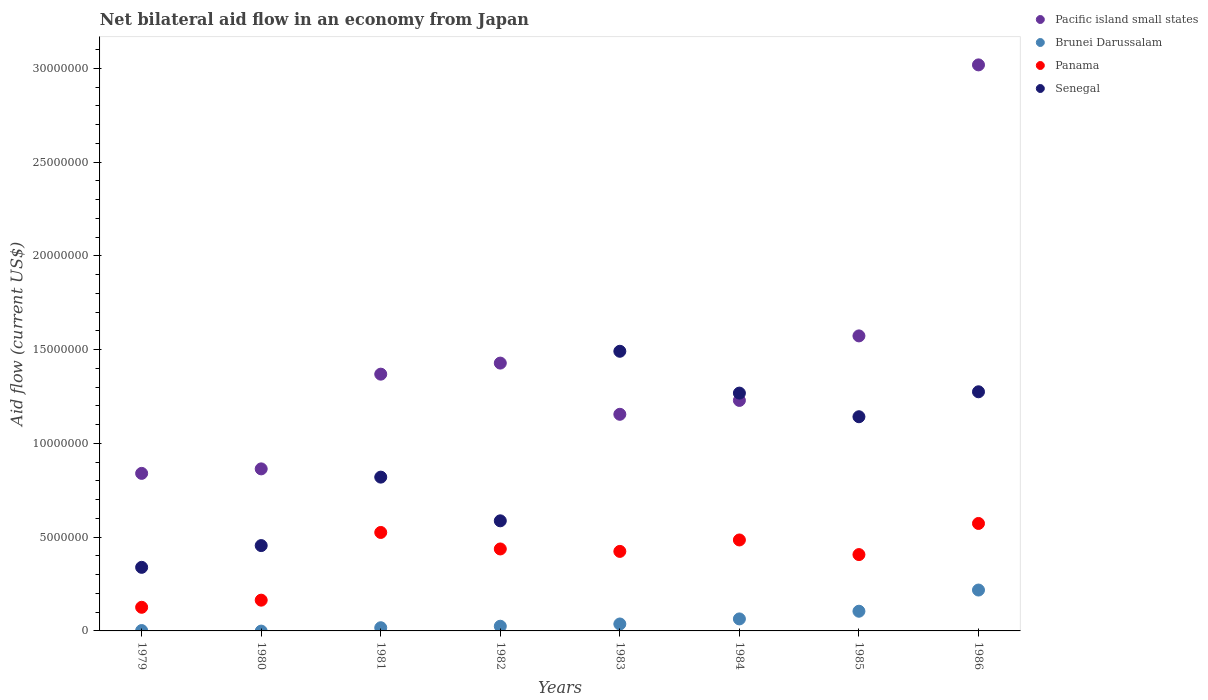Is the number of dotlines equal to the number of legend labels?
Your answer should be compact. No. What is the net bilateral aid flow in Pacific island small states in 1986?
Provide a short and direct response. 3.02e+07. Across all years, what is the maximum net bilateral aid flow in Panama?
Make the answer very short. 5.73e+06. Across all years, what is the minimum net bilateral aid flow in Senegal?
Offer a very short reply. 3.39e+06. What is the total net bilateral aid flow in Panama in the graph?
Provide a succinct answer. 3.14e+07. What is the difference between the net bilateral aid flow in Senegal in 1982 and that in 1983?
Ensure brevity in your answer.  -9.04e+06. What is the difference between the net bilateral aid flow in Brunei Darussalam in 1984 and the net bilateral aid flow in Pacific island small states in 1979?
Ensure brevity in your answer.  -7.76e+06. What is the average net bilateral aid flow in Senegal per year?
Your answer should be very brief. 9.22e+06. In the year 1985, what is the difference between the net bilateral aid flow in Senegal and net bilateral aid flow in Brunei Darussalam?
Your answer should be very brief. 1.04e+07. What is the ratio of the net bilateral aid flow in Brunei Darussalam in 1979 to that in 1983?
Give a very brief answer. 0.05. Is the net bilateral aid flow in Senegal in 1982 less than that in 1985?
Your response must be concise. Yes. Is the difference between the net bilateral aid flow in Senegal in 1981 and 1985 greater than the difference between the net bilateral aid flow in Brunei Darussalam in 1981 and 1985?
Provide a succinct answer. No. What is the difference between the highest and the lowest net bilateral aid flow in Senegal?
Provide a succinct answer. 1.15e+07. Is the net bilateral aid flow in Brunei Darussalam strictly greater than the net bilateral aid flow in Senegal over the years?
Provide a short and direct response. No. How many dotlines are there?
Make the answer very short. 4. What is the difference between two consecutive major ticks on the Y-axis?
Your answer should be compact. 5.00e+06. Are the values on the major ticks of Y-axis written in scientific E-notation?
Make the answer very short. No. Does the graph contain grids?
Provide a succinct answer. No. How many legend labels are there?
Offer a very short reply. 4. How are the legend labels stacked?
Keep it short and to the point. Vertical. What is the title of the graph?
Ensure brevity in your answer.  Net bilateral aid flow in an economy from Japan. What is the label or title of the X-axis?
Offer a terse response. Years. What is the Aid flow (current US$) in Pacific island small states in 1979?
Your answer should be very brief. 8.40e+06. What is the Aid flow (current US$) in Brunei Darussalam in 1979?
Your answer should be compact. 2.00e+04. What is the Aid flow (current US$) of Panama in 1979?
Your response must be concise. 1.26e+06. What is the Aid flow (current US$) in Senegal in 1979?
Provide a succinct answer. 3.39e+06. What is the Aid flow (current US$) in Pacific island small states in 1980?
Make the answer very short. 8.64e+06. What is the Aid flow (current US$) in Brunei Darussalam in 1980?
Provide a short and direct response. 0. What is the Aid flow (current US$) in Panama in 1980?
Your answer should be compact. 1.64e+06. What is the Aid flow (current US$) in Senegal in 1980?
Keep it short and to the point. 4.55e+06. What is the Aid flow (current US$) of Pacific island small states in 1981?
Ensure brevity in your answer.  1.37e+07. What is the Aid flow (current US$) in Panama in 1981?
Provide a succinct answer. 5.25e+06. What is the Aid flow (current US$) of Senegal in 1981?
Make the answer very short. 8.20e+06. What is the Aid flow (current US$) in Pacific island small states in 1982?
Make the answer very short. 1.43e+07. What is the Aid flow (current US$) in Brunei Darussalam in 1982?
Provide a short and direct response. 2.50e+05. What is the Aid flow (current US$) of Panama in 1982?
Offer a very short reply. 4.37e+06. What is the Aid flow (current US$) of Senegal in 1982?
Make the answer very short. 5.87e+06. What is the Aid flow (current US$) of Pacific island small states in 1983?
Keep it short and to the point. 1.16e+07. What is the Aid flow (current US$) in Brunei Darussalam in 1983?
Your response must be concise. 3.70e+05. What is the Aid flow (current US$) in Panama in 1983?
Provide a succinct answer. 4.24e+06. What is the Aid flow (current US$) in Senegal in 1983?
Keep it short and to the point. 1.49e+07. What is the Aid flow (current US$) in Pacific island small states in 1984?
Ensure brevity in your answer.  1.23e+07. What is the Aid flow (current US$) of Brunei Darussalam in 1984?
Offer a terse response. 6.40e+05. What is the Aid flow (current US$) of Panama in 1984?
Offer a terse response. 4.85e+06. What is the Aid flow (current US$) in Senegal in 1984?
Offer a very short reply. 1.27e+07. What is the Aid flow (current US$) in Pacific island small states in 1985?
Your answer should be compact. 1.57e+07. What is the Aid flow (current US$) of Brunei Darussalam in 1985?
Provide a short and direct response. 1.05e+06. What is the Aid flow (current US$) of Panama in 1985?
Your response must be concise. 4.07e+06. What is the Aid flow (current US$) in Senegal in 1985?
Your answer should be very brief. 1.14e+07. What is the Aid flow (current US$) of Pacific island small states in 1986?
Make the answer very short. 3.02e+07. What is the Aid flow (current US$) of Brunei Darussalam in 1986?
Offer a very short reply. 2.18e+06. What is the Aid flow (current US$) in Panama in 1986?
Ensure brevity in your answer.  5.73e+06. What is the Aid flow (current US$) in Senegal in 1986?
Provide a succinct answer. 1.28e+07. Across all years, what is the maximum Aid flow (current US$) in Pacific island small states?
Ensure brevity in your answer.  3.02e+07. Across all years, what is the maximum Aid flow (current US$) of Brunei Darussalam?
Make the answer very short. 2.18e+06. Across all years, what is the maximum Aid flow (current US$) of Panama?
Keep it short and to the point. 5.73e+06. Across all years, what is the maximum Aid flow (current US$) in Senegal?
Make the answer very short. 1.49e+07. Across all years, what is the minimum Aid flow (current US$) in Pacific island small states?
Your answer should be very brief. 8.40e+06. Across all years, what is the minimum Aid flow (current US$) of Brunei Darussalam?
Your answer should be compact. 0. Across all years, what is the minimum Aid flow (current US$) in Panama?
Offer a terse response. 1.26e+06. Across all years, what is the minimum Aid flow (current US$) of Senegal?
Make the answer very short. 3.39e+06. What is the total Aid flow (current US$) in Pacific island small states in the graph?
Provide a short and direct response. 1.15e+08. What is the total Aid flow (current US$) in Brunei Darussalam in the graph?
Keep it short and to the point. 4.68e+06. What is the total Aid flow (current US$) in Panama in the graph?
Offer a very short reply. 3.14e+07. What is the total Aid flow (current US$) of Senegal in the graph?
Offer a terse response. 7.38e+07. What is the difference between the Aid flow (current US$) of Pacific island small states in 1979 and that in 1980?
Offer a very short reply. -2.40e+05. What is the difference between the Aid flow (current US$) in Panama in 1979 and that in 1980?
Your answer should be compact. -3.80e+05. What is the difference between the Aid flow (current US$) in Senegal in 1979 and that in 1980?
Your answer should be compact. -1.16e+06. What is the difference between the Aid flow (current US$) of Pacific island small states in 1979 and that in 1981?
Give a very brief answer. -5.29e+06. What is the difference between the Aid flow (current US$) of Panama in 1979 and that in 1981?
Provide a short and direct response. -3.99e+06. What is the difference between the Aid flow (current US$) in Senegal in 1979 and that in 1981?
Your answer should be compact. -4.81e+06. What is the difference between the Aid flow (current US$) of Pacific island small states in 1979 and that in 1982?
Provide a short and direct response. -5.88e+06. What is the difference between the Aid flow (current US$) in Brunei Darussalam in 1979 and that in 1982?
Ensure brevity in your answer.  -2.30e+05. What is the difference between the Aid flow (current US$) in Panama in 1979 and that in 1982?
Give a very brief answer. -3.11e+06. What is the difference between the Aid flow (current US$) of Senegal in 1979 and that in 1982?
Provide a short and direct response. -2.48e+06. What is the difference between the Aid flow (current US$) of Pacific island small states in 1979 and that in 1983?
Give a very brief answer. -3.15e+06. What is the difference between the Aid flow (current US$) of Brunei Darussalam in 1979 and that in 1983?
Your answer should be very brief. -3.50e+05. What is the difference between the Aid flow (current US$) of Panama in 1979 and that in 1983?
Keep it short and to the point. -2.98e+06. What is the difference between the Aid flow (current US$) in Senegal in 1979 and that in 1983?
Provide a short and direct response. -1.15e+07. What is the difference between the Aid flow (current US$) in Pacific island small states in 1979 and that in 1984?
Keep it short and to the point. -3.89e+06. What is the difference between the Aid flow (current US$) of Brunei Darussalam in 1979 and that in 1984?
Give a very brief answer. -6.20e+05. What is the difference between the Aid flow (current US$) of Panama in 1979 and that in 1984?
Give a very brief answer. -3.59e+06. What is the difference between the Aid flow (current US$) in Senegal in 1979 and that in 1984?
Offer a very short reply. -9.29e+06. What is the difference between the Aid flow (current US$) in Pacific island small states in 1979 and that in 1985?
Ensure brevity in your answer.  -7.33e+06. What is the difference between the Aid flow (current US$) in Brunei Darussalam in 1979 and that in 1985?
Keep it short and to the point. -1.03e+06. What is the difference between the Aid flow (current US$) of Panama in 1979 and that in 1985?
Give a very brief answer. -2.81e+06. What is the difference between the Aid flow (current US$) of Senegal in 1979 and that in 1985?
Offer a terse response. -8.03e+06. What is the difference between the Aid flow (current US$) in Pacific island small states in 1979 and that in 1986?
Keep it short and to the point. -2.18e+07. What is the difference between the Aid flow (current US$) of Brunei Darussalam in 1979 and that in 1986?
Keep it short and to the point. -2.16e+06. What is the difference between the Aid flow (current US$) in Panama in 1979 and that in 1986?
Offer a very short reply. -4.47e+06. What is the difference between the Aid flow (current US$) of Senegal in 1979 and that in 1986?
Ensure brevity in your answer.  -9.36e+06. What is the difference between the Aid flow (current US$) in Pacific island small states in 1980 and that in 1981?
Your response must be concise. -5.05e+06. What is the difference between the Aid flow (current US$) of Panama in 1980 and that in 1981?
Give a very brief answer. -3.61e+06. What is the difference between the Aid flow (current US$) of Senegal in 1980 and that in 1981?
Your response must be concise. -3.65e+06. What is the difference between the Aid flow (current US$) in Pacific island small states in 1980 and that in 1982?
Your answer should be very brief. -5.64e+06. What is the difference between the Aid flow (current US$) of Panama in 1980 and that in 1982?
Your answer should be compact. -2.73e+06. What is the difference between the Aid flow (current US$) of Senegal in 1980 and that in 1982?
Your answer should be compact. -1.32e+06. What is the difference between the Aid flow (current US$) in Pacific island small states in 1980 and that in 1983?
Give a very brief answer. -2.91e+06. What is the difference between the Aid flow (current US$) in Panama in 1980 and that in 1983?
Your answer should be compact. -2.60e+06. What is the difference between the Aid flow (current US$) of Senegal in 1980 and that in 1983?
Your answer should be compact. -1.04e+07. What is the difference between the Aid flow (current US$) in Pacific island small states in 1980 and that in 1984?
Provide a succinct answer. -3.65e+06. What is the difference between the Aid flow (current US$) in Panama in 1980 and that in 1984?
Provide a succinct answer. -3.21e+06. What is the difference between the Aid flow (current US$) in Senegal in 1980 and that in 1984?
Provide a succinct answer. -8.13e+06. What is the difference between the Aid flow (current US$) in Pacific island small states in 1980 and that in 1985?
Your answer should be compact. -7.09e+06. What is the difference between the Aid flow (current US$) in Panama in 1980 and that in 1985?
Your answer should be very brief. -2.43e+06. What is the difference between the Aid flow (current US$) of Senegal in 1980 and that in 1985?
Your answer should be very brief. -6.87e+06. What is the difference between the Aid flow (current US$) of Pacific island small states in 1980 and that in 1986?
Offer a terse response. -2.15e+07. What is the difference between the Aid flow (current US$) of Panama in 1980 and that in 1986?
Offer a terse response. -4.09e+06. What is the difference between the Aid flow (current US$) in Senegal in 1980 and that in 1986?
Keep it short and to the point. -8.20e+06. What is the difference between the Aid flow (current US$) of Pacific island small states in 1981 and that in 1982?
Your answer should be compact. -5.90e+05. What is the difference between the Aid flow (current US$) of Panama in 1981 and that in 1982?
Your response must be concise. 8.80e+05. What is the difference between the Aid flow (current US$) of Senegal in 1981 and that in 1982?
Offer a very short reply. 2.33e+06. What is the difference between the Aid flow (current US$) of Pacific island small states in 1981 and that in 1983?
Give a very brief answer. 2.14e+06. What is the difference between the Aid flow (current US$) of Panama in 1981 and that in 1983?
Provide a succinct answer. 1.01e+06. What is the difference between the Aid flow (current US$) in Senegal in 1981 and that in 1983?
Provide a short and direct response. -6.71e+06. What is the difference between the Aid flow (current US$) of Pacific island small states in 1981 and that in 1984?
Your answer should be compact. 1.40e+06. What is the difference between the Aid flow (current US$) in Brunei Darussalam in 1981 and that in 1984?
Make the answer very short. -4.70e+05. What is the difference between the Aid flow (current US$) in Panama in 1981 and that in 1984?
Your answer should be compact. 4.00e+05. What is the difference between the Aid flow (current US$) in Senegal in 1981 and that in 1984?
Your answer should be very brief. -4.48e+06. What is the difference between the Aid flow (current US$) of Pacific island small states in 1981 and that in 1985?
Provide a short and direct response. -2.04e+06. What is the difference between the Aid flow (current US$) in Brunei Darussalam in 1981 and that in 1985?
Offer a very short reply. -8.80e+05. What is the difference between the Aid flow (current US$) of Panama in 1981 and that in 1985?
Make the answer very short. 1.18e+06. What is the difference between the Aid flow (current US$) in Senegal in 1981 and that in 1985?
Your answer should be very brief. -3.22e+06. What is the difference between the Aid flow (current US$) in Pacific island small states in 1981 and that in 1986?
Make the answer very short. -1.65e+07. What is the difference between the Aid flow (current US$) in Brunei Darussalam in 1981 and that in 1986?
Offer a very short reply. -2.01e+06. What is the difference between the Aid flow (current US$) in Panama in 1981 and that in 1986?
Keep it short and to the point. -4.80e+05. What is the difference between the Aid flow (current US$) in Senegal in 1981 and that in 1986?
Your answer should be very brief. -4.55e+06. What is the difference between the Aid flow (current US$) in Pacific island small states in 1982 and that in 1983?
Your answer should be compact. 2.73e+06. What is the difference between the Aid flow (current US$) of Brunei Darussalam in 1982 and that in 1983?
Provide a short and direct response. -1.20e+05. What is the difference between the Aid flow (current US$) of Senegal in 1982 and that in 1983?
Ensure brevity in your answer.  -9.04e+06. What is the difference between the Aid flow (current US$) of Pacific island small states in 1982 and that in 1984?
Keep it short and to the point. 1.99e+06. What is the difference between the Aid flow (current US$) in Brunei Darussalam in 1982 and that in 1984?
Make the answer very short. -3.90e+05. What is the difference between the Aid flow (current US$) in Panama in 1982 and that in 1984?
Keep it short and to the point. -4.80e+05. What is the difference between the Aid flow (current US$) of Senegal in 1982 and that in 1984?
Give a very brief answer. -6.81e+06. What is the difference between the Aid flow (current US$) in Pacific island small states in 1982 and that in 1985?
Keep it short and to the point. -1.45e+06. What is the difference between the Aid flow (current US$) of Brunei Darussalam in 1982 and that in 1985?
Your answer should be very brief. -8.00e+05. What is the difference between the Aid flow (current US$) of Senegal in 1982 and that in 1985?
Make the answer very short. -5.55e+06. What is the difference between the Aid flow (current US$) of Pacific island small states in 1982 and that in 1986?
Provide a short and direct response. -1.59e+07. What is the difference between the Aid flow (current US$) of Brunei Darussalam in 1982 and that in 1986?
Your answer should be very brief. -1.93e+06. What is the difference between the Aid flow (current US$) in Panama in 1982 and that in 1986?
Offer a terse response. -1.36e+06. What is the difference between the Aid flow (current US$) in Senegal in 1982 and that in 1986?
Provide a short and direct response. -6.88e+06. What is the difference between the Aid flow (current US$) in Pacific island small states in 1983 and that in 1984?
Provide a succinct answer. -7.40e+05. What is the difference between the Aid flow (current US$) of Brunei Darussalam in 1983 and that in 1984?
Offer a terse response. -2.70e+05. What is the difference between the Aid flow (current US$) in Panama in 1983 and that in 1984?
Offer a terse response. -6.10e+05. What is the difference between the Aid flow (current US$) of Senegal in 1983 and that in 1984?
Your response must be concise. 2.23e+06. What is the difference between the Aid flow (current US$) of Pacific island small states in 1983 and that in 1985?
Your answer should be very brief. -4.18e+06. What is the difference between the Aid flow (current US$) in Brunei Darussalam in 1983 and that in 1985?
Ensure brevity in your answer.  -6.80e+05. What is the difference between the Aid flow (current US$) of Senegal in 1983 and that in 1985?
Keep it short and to the point. 3.49e+06. What is the difference between the Aid flow (current US$) in Pacific island small states in 1983 and that in 1986?
Give a very brief answer. -1.86e+07. What is the difference between the Aid flow (current US$) in Brunei Darussalam in 1983 and that in 1986?
Provide a short and direct response. -1.81e+06. What is the difference between the Aid flow (current US$) in Panama in 1983 and that in 1986?
Offer a terse response. -1.49e+06. What is the difference between the Aid flow (current US$) in Senegal in 1983 and that in 1986?
Give a very brief answer. 2.16e+06. What is the difference between the Aid flow (current US$) of Pacific island small states in 1984 and that in 1985?
Make the answer very short. -3.44e+06. What is the difference between the Aid flow (current US$) of Brunei Darussalam in 1984 and that in 1985?
Make the answer very short. -4.10e+05. What is the difference between the Aid flow (current US$) in Panama in 1984 and that in 1985?
Your answer should be compact. 7.80e+05. What is the difference between the Aid flow (current US$) in Senegal in 1984 and that in 1985?
Provide a short and direct response. 1.26e+06. What is the difference between the Aid flow (current US$) in Pacific island small states in 1984 and that in 1986?
Keep it short and to the point. -1.79e+07. What is the difference between the Aid flow (current US$) in Brunei Darussalam in 1984 and that in 1986?
Keep it short and to the point. -1.54e+06. What is the difference between the Aid flow (current US$) in Panama in 1984 and that in 1986?
Your answer should be compact. -8.80e+05. What is the difference between the Aid flow (current US$) in Senegal in 1984 and that in 1986?
Offer a terse response. -7.00e+04. What is the difference between the Aid flow (current US$) in Pacific island small states in 1985 and that in 1986?
Ensure brevity in your answer.  -1.44e+07. What is the difference between the Aid flow (current US$) in Brunei Darussalam in 1985 and that in 1986?
Your answer should be compact. -1.13e+06. What is the difference between the Aid flow (current US$) of Panama in 1985 and that in 1986?
Provide a short and direct response. -1.66e+06. What is the difference between the Aid flow (current US$) in Senegal in 1985 and that in 1986?
Keep it short and to the point. -1.33e+06. What is the difference between the Aid flow (current US$) of Pacific island small states in 1979 and the Aid flow (current US$) of Panama in 1980?
Provide a short and direct response. 6.76e+06. What is the difference between the Aid flow (current US$) in Pacific island small states in 1979 and the Aid flow (current US$) in Senegal in 1980?
Offer a very short reply. 3.85e+06. What is the difference between the Aid flow (current US$) of Brunei Darussalam in 1979 and the Aid flow (current US$) of Panama in 1980?
Your response must be concise. -1.62e+06. What is the difference between the Aid flow (current US$) of Brunei Darussalam in 1979 and the Aid flow (current US$) of Senegal in 1980?
Ensure brevity in your answer.  -4.53e+06. What is the difference between the Aid flow (current US$) in Panama in 1979 and the Aid flow (current US$) in Senegal in 1980?
Ensure brevity in your answer.  -3.29e+06. What is the difference between the Aid flow (current US$) in Pacific island small states in 1979 and the Aid flow (current US$) in Brunei Darussalam in 1981?
Your answer should be compact. 8.23e+06. What is the difference between the Aid flow (current US$) in Pacific island small states in 1979 and the Aid flow (current US$) in Panama in 1981?
Offer a very short reply. 3.15e+06. What is the difference between the Aid flow (current US$) of Brunei Darussalam in 1979 and the Aid flow (current US$) of Panama in 1981?
Provide a succinct answer. -5.23e+06. What is the difference between the Aid flow (current US$) in Brunei Darussalam in 1979 and the Aid flow (current US$) in Senegal in 1981?
Your answer should be compact. -8.18e+06. What is the difference between the Aid flow (current US$) of Panama in 1979 and the Aid flow (current US$) of Senegal in 1981?
Make the answer very short. -6.94e+06. What is the difference between the Aid flow (current US$) in Pacific island small states in 1979 and the Aid flow (current US$) in Brunei Darussalam in 1982?
Your response must be concise. 8.15e+06. What is the difference between the Aid flow (current US$) of Pacific island small states in 1979 and the Aid flow (current US$) of Panama in 1982?
Your answer should be very brief. 4.03e+06. What is the difference between the Aid flow (current US$) of Pacific island small states in 1979 and the Aid flow (current US$) of Senegal in 1982?
Provide a succinct answer. 2.53e+06. What is the difference between the Aid flow (current US$) in Brunei Darussalam in 1979 and the Aid flow (current US$) in Panama in 1982?
Your answer should be compact. -4.35e+06. What is the difference between the Aid flow (current US$) in Brunei Darussalam in 1979 and the Aid flow (current US$) in Senegal in 1982?
Your answer should be very brief. -5.85e+06. What is the difference between the Aid flow (current US$) in Panama in 1979 and the Aid flow (current US$) in Senegal in 1982?
Provide a short and direct response. -4.61e+06. What is the difference between the Aid flow (current US$) in Pacific island small states in 1979 and the Aid flow (current US$) in Brunei Darussalam in 1983?
Provide a short and direct response. 8.03e+06. What is the difference between the Aid flow (current US$) of Pacific island small states in 1979 and the Aid flow (current US$) of Panama in 1983?
Provide a succinct answer. 4.16e+06. What is the difference between the Aid flow (current US$) of Pacific island small states in 1979 and the Aid flow (current US$) of Senegal in 1983?
Keep it short and to the point. -6.51e+06. What is the difference between the Aid flow (current US$) of Brunei Darussalam in 1979 and the Aid flow (current US$) of Panama in 1983?
Ensure brevity in your answer.  -4.22e+06. What is the difference between the Aid flow (current US$) in Brunei Darussalam in 1979 and the Aid flow (current US$) in Senegal in 1983?
Provide a short and direct response. -1.49e+07. What is the difference between the Aid flow (current US$) in Panama in 1979 and the Aid flow (current US$) in Senegal in 1983?
Give a very brief answer. -1.36e+07. What is the difference between the Aid flow (current US$) in Pacific island small states in 1979 and the Aid flow (current US$) in Brunei Darussalam in 1984?
Ensure brevity in your answer.  7.76e+06. What is the difference between the Aid flow (current US$) in Pacific island small states in 1979 and the Aid flow (current US$) in Panama in 1984?
Provide a short and direct response. 3.55e+06. What is the difference between the Aid flow (current US$) of Pacific island small states in 1979 and the Aid flow (current US$) of Senegal in 1984?
Provide a short and direct response. -4.28e+06. What is the difference between the Aid flow (current US$) in Brunei Darussalam in 1979 and the Aid flow (current US$) in Panama in 1984?
Your answer should be very brief. -4.83e+06. What is the difference between the Aid flow (current US$) in Brunei Darussalam in 1979 and the Aid flow (current US$) in Senegal in 1984?
Give a very brief answer. -1.27e+07. What is the difference between the Aid flow (current US$) in Panama in 1979 and the Aid flow (current US$) in Senegal in 1984?
Your response must be concise. -1.14e+07. What is the difference between the Aid flow (current US$) in Pacific island small states in 1979 and the Aid flow (current US$) in Brunei Darussalam in 1985?
Offer a terse response. 7.35e+06. What is the difference between the Aid flow (current US$) of Pacific island small states in 1979 and the Aid flow (current US$) of Panama in 1985?
Provide a succinct answer. 4.33e+06. What is the difference between the Aid flow (current US$) in Pacific island small states in 1979 and the Aid flow (current US$) in Senegal in 1985?
Your answer should be compact. -3.02e+06. What is the difference between the Aid flow (current US$) of Brunei Darussalam in 1979 and the Aid flow (current US$) of Panama in 1985?
Ensure brevity in your answer.  -4.05e+06. What is the difference between the Aid flow (current US$) of Brunei Darussalam in 1979 and the Aid flow (current US$) of Senegal in 1985?
Your response must be concise. -1.14e+07. What is the difference between the Aid flow (current US$) in Panama in 1979 and the Aid flow (current US$) in Senegal in 1985?
Give a very brief answer. -1.02e+07. What is the difference between the Aid flow (current US$) of Pacific island small states in 1979 and the Aid flow (current US$) of Brunei Darussalam in 1986?
Keep it short and to the point. 6.22e+06. What is the difference between the Aid flow (current US$) in Pacific island small states in 1979 and the Aid flow (current US$) in Panama in 1986?
Your answer should be very brief. 2.67e+06. What is the difference between the Aid flow (current US$) of Pacific island small states in 1979 and the Aid flow (current US$) of Senegal in 1986?
Your answer should be compact. -4.35e+06. What is the difference between the Aid flow (current US$) in Brunei Darussalam in 1979 and the Aid flow (current US$) in Panama in 1986?
Keep it short and to the point. -5.71e+06. What is the difference between the Aid flow (current US$) in Brunei Darussalam in 1979 and the Aid flow (current US$) in Senegal in 1986?
Your answer should be very brief. -1.27e+07. What is the difference between the Aid flow (current US$) in Panama in 1979 and the Aid flow (current US$) in Senegal in 1986?
Keep it short and to the point. -1.15e+07. What is the difference between the Aid flow (current US$) of Pacific island small states in 1980 and the Aid flow (current US$) of Brunei Darussalam in 1981?
Your response must be concise. 8.47e+06. What is the difference between the Aid flow (current US$) of Pacific island small states in 1980 and the Aid flow (current US$) of Panama in 1981?
Your response must be concise. 3.39e+06. What is the difference between the Aid flow (current US$) in Pacific island small states in 1980 and the Aid flow (current US$) in Senegal in 1981?
Keep it short and to the point. 4.40e+05. What is the difference between the Aid flow (current US$) of Panama in 1980 and the Aid flow (current US$) of Senegal in 1981?
Give a very brief answer. -6.56e+06. What is the difference between the Aid flow (current US$) in Pacific island small states in 1980 and the Aid flow (current US$) in Brunei Darussalam in 1982?
Make the answer very short. 8.39e+06. What is the difference between the Aid flow (current US$) of Pacific island small states in 1980 and the Aid flow (current US$) of Panama in 1982?
Your answer should be compact. 4.27e+06. What is the difference between the Aid flow (current US$) in Pacific island small states in 1980 and the Aid flow (current US$) in Senegal in 1982?
Your answer should be very brief. 2.77e+06. What is the difference between the Aid flow (current US$) of Panama in 1980 and the Aid flow (current US$) of Senegal in 1982?
Provide a succinct answer. -4.23e+06. What is the difference between the Aid flow (current US$) of Pacific island small states in 1980 and the Aid flow (current US$) of Brunei Darussalam in 1983?
Give a very brief answer. 8.27e+06. What is the difference between the Aid flow (current US$) of Pacific island small states in 1980 and the Aid flow (current US$) of Panama in 1983?
Offer a terse response. 4.40e+06. What is the difference between the Aid flow (current US$) in Pacific island small states in 1980 and the Aid flow (current US$) in Senegal in 1983?
Keep it short and to the point. -6.27e+06. What is the difference between the Aid flow (current US$) of Panama in 1980 and the Aid flow (current US$) of Senegal in 1983?
Your response must be concise. -1.33e+07. What is the difference between the Aid flow (current US$) in Pacific island small states in 1980 and the Aid flow (current US$) in Brunei Darussalam in 1984?
Keep it short and to the point. 8.00e+06. What is the difference between the Aid flow (current US$) of Pacific island small states in 1980 and the Aid flow (current US$) of Panama in 1984?
Ensure brevity in your answer.  3.79e+06. What is the difference between the Aid flow (current US$) in Pacific island small states in 1980 and the Aid flow (current US$) in Senegal in 1984?
Offer a terse response. -4.04e+06. What is the difference between the Aid flow (current US$) in Panama in 1980 and the Aid flow (current US$) in Senegal in 1984?
Keep it short and to the point. -1.10e+07. What is the difference between the Aid flow (current US$) in Pacific island small states in 1980 and the Aid flow (current US$) in Brunei Darussalam in 1985?
Make the answer very short. 7.59e+06. What is the difference between the Aid flow (current US$) of Pacific island small states in 1980 and the Aid flow (current US$) of Panama in 1985?
Make the answer very short. 4.57e+06. What is the difference between the Aid flow (current US$) of Pacific island small states in 1980 and the Aid flow (current US$) of Senegal in 1985?
Provide a succinct answer. -2.78e+06. What is the difference between the Aid flow (current US$) of Panama in 1980 and the Aid flow (current US$) of Senegal in 1985?
Provide a short and direct response. -9.78e+06. What is the difference between the Aid flow (current US$) of Pacific island small states in 1980 and the Aid flow (current US$) of Brunei Darussalam in 1986?
Your answer should be compact. 6.46e+06. What is the difference between the Aid flow (current US$) in Pacific island small states in 1980 and the Aid flow (current US$) in Panama in 1986?
Ensure brevity in your answer.  2.91e+06. What is the difference between the Aid flow (current US$) of Pacific island small states in 1980 and the Aid flow (current US$) of Senegal in 1986?
Provide a short and direct response. -4.11e+06. What is the difference between the Aid flow (current US$) of Panama in 1980 and the Aid flow (current US$) of Senegal in 1986?
Ensure brevity in your answer.  -1.11e+07. What is the difference between the Aid flow (current US$) of Pacific island small states in 1981 and the Aid flow (current US$) of Brunei Darussalam in 1982?
Make the answer very short. 1.34e+07. What is the difference between the Aid flow (current US$) in Pacific island small states in 1981 and the Aid flow (current US$) in Panama in 1982?
Provide a succinct answer. 9.32e+06. What is the difference between the Aid flow (current US$) in Pacific island small states in 1981 and the Aid flow (current US$) in Senegal in 1982?
Ensure brevity in your answer.  7.82e+06. What is the difference between the Aid flow (current US$) of Brunei Darussalam in 1981 and the Aid flow (current US$) of Panama in 1982?
Keep it short and to the point. -4.20e+06. What is the difference between the Aid flow (current US$) in Brunei Darussalam in 1981 and the Aid flow (current US$) in Senegal in 1982?
Keep it short and to the point. -5.70e+06. What is the difference between the Aid flow (current US$) in Panama in 1981 and the Aid flow (current US$) in Senegal in 1982?
Offer a very short reply. -6.20e+05. What is the difference between the Aid flow (current US$) of Pacific island small states in 1981 and the Aid flow (current US$) of Brunei Darussalam in 1983?
Your answer should be very brief. 1.33e+07. What is the difference between the Aid flow (current US$) in Pacific island small states in 1981 and the Aid flow (current US$) in Panama in 1983?
Provide a succinct answer. 9.45e+06. What is the difference between the Aid flow (current US$) of Pacific island small states in 1981 and the Aid flow (current US$) of Senegal in 1983?
Your answer should be very brief. -1.22e+06. What is the difference between the Aid flow (current US$) of Brunei Darussalam in 1981 and the Aid flow (current US$) of Panama in 1983?
Give a very brief answer. -4.07e+06. What is the difference between the Aid flow (current US$) in Brunei Darussalam in 1981 and the Aid flow (current US$) in Senegal in 1983?
Ensure brevity in your answer.  -1.47e+07. What is the difference between the Aid flow (current US$) in Panama in 1981 and the Aid flow (current US$) in Senegal in 1983?
Ensure brevity in your answer.  -9.66e+06. What is the difference between the Aid flow (current US$) of Pacific island small states in 1981 and the Aid flow (current US$) of Brunei Darussalam in 1984?
Offer a terse response. 1.30e+07. What is the difference between the Aid flow (current US$) of Pacific island small states in 1981 and the Aid flow (current US$) of Panama in 1984?
Provide a short and direct response. 8.84e+06. What is the difference between the Aid flow (current US$) of Pacific island small states in 1981 and the Aid flow (current US$) of Senegal in 1984?
Offer a terse response. 1.01e+06. What is the difference between the Aid flow (current US$) of Brunei Darussalam in 1981 and the Aid flow (current US$) of Panama in 1984?
Your answer should be compact. -4.68e+06. What is the difference between the Aid flow (current US$) of Brunei Darussalam in 1981 and the Aid flow (current US$) of Senegal in 1984?
Offer a terse response. -1.25e+07. What is the difference between the Aid flow (current US$) in Panama in 1981 and the Aid flow (current US$) in Senegal in 1984?
Offer a very short reply. -7.43e+06. What is the difference between the Aid flow (current US$) in Pacific island small states in 1981 and the Aid flow (current US$) in Brunei Darussalam in 1985?
Make the answer very short. 1.26e+07. What is the difference between the Aid flow (current US$) of Pacific island small states in 1981 and the Aid flow (current US$) of Panama in 1985?
Offer a very short reply. 9.62e+06. What is the difference between the Aid flow (current US$) in Pacific island small states in 1981 and the Aid flow (current US$) in Senegal in 1985?
Your answer should be very brief. 2.27e+06. What is the difference between the Aid flow (current US$) in Brunei Darussalam in 1981 and the Aid flow (current US$) in Panama in 1985?
Make the answer very short. -3.90e+06. What is the difference between the Aid flow (current US$) of Brunei Darussalam in 1981 and the Aid flow (current US$) of Senegal in 1985?
Make the answer very short. -1.12e+07. What is the difference between the Aid flow (current US$) in Panama in 1981 and the Aid flow (current US$) in Senegal in 1985?
Offer a very short reply. -6.17e+06. What is the difference between the Aid flow (current US$) in Pacific island small states in 1981 and the Aid flow (current US$) in Brunei Darussalam in 1986?
Keep it short and to the point. 1.15e+07. What is the difference between the Aid flow (current US$) of Pacific island small states in 1981 and the Aid flow (current US$) of Panama in 1986?
Provide a succinct answer. 7.96e+06. What is the difference between the Aid flow (current US$) of Pacific island small states in 1981 and the Aid flow (current US$) of Senegal in 1986?
Ensure brevity in your answer.  9.40e+05. What is the difference between the Aid flow (current US$) of Brunei Darussalam in 1981 and the Aid flow (current US$) of Panama in 1986?
Provide a succinct answer. -5.56e+06. What is the difference between the Aid flow (current US$) of Brunei Darussalam in 1981 and the Aid flow (current US$) of Senegal in 1986?
Your answer should be very brief. -1.26e+07. What is the difference between the Aid flow (current US$) in Panama in 1981 and the Aid flow (current US$) in Senegal in 1986?
Your answer should be compact. -7.50e+06. What is the difference between the Aid flow (current US$) in Pacific island small states in 1982 and the Aid flow (current US$) in Brunei Darussalam in 1983?
Provide a short and direct response. 1.39e+07. What is the difference between the Aid flow (current US$) in Pacific island small states in 1982 and the Aid flow (current US$) in Panama in 1983?
Your answer should be compact. 1.00e+07. What is the difference between the Aid flow (current US$) of Pacific island small states in 1982 and the Aid flow (current US$) of Senegal in 1983?
Provide a short and direct response. -6.30e+05. What is the difference between the Aid flow (current US$) of Brunei Darussalam in 1982 and the Aid flow (current US$) of Panama in 1983?
Ensure brevity in your answer.  -3.99e+06. What is the difference between the Aid flow (current US$) in Brunei Darussalam in 1982 and the Aid flow (current US$) in Senegal in 1983?
Provide a short and direct response. -1.47e+07. What is the difference between the Aid flow (current US$) of Panama in 1982 and the Aid flow (current US$) of Senegal in 1983?
Offer a very short reply. -1.05e+07. What is the difference between the Aid flow (current US$) of Pacific island small states in 1982 and the Aid flow (current US$) of Brunei Darussalam in 1984?
Make the answer very short. 1.36e+07. What is the difference between the Aid flow (current US$) in Pacific island small states in 1982 and the Aid flow (current US$) in Panama in 1984?
Give a very brief answer. 9.43e+06. What is the difference between the Aid flow (current US$) in Pacific island small states in 1982 and the Aid flow (current US$) in Senegal in 1984?
Your response must be concise. 1.60e+06. What is the difference between the Aid flow (current US$) of Brunei Darussalam in 1982 and the Aid flow (current US$) of Panama in 1984?
Offer a terse response. -4.60e+06. What is the difference between the Aid flow (current US$) in Brunei Darussalam in 1982 and the Aid flow (current US$) in Senegal in 1984?
Keep it short and to the point. -1.24e+07. What is the difference between the Aid flow (current US$) in Panama in 1982 and the Aid flow (current US$) in Senegal in 1984?
Make the answer very short. -8.31e+06. What is the difference between the Aid flow (current US$) in Pacific island small states in 1982 and the Aid flow (current US$) in Brunei Darussalam in 1985?
Give a very brief answer. 1.32e+07. What is the difference between the Aid flow (current US$) in Pacific island small states in 1982 and the Aid flow (current US$) in Panama in 1985?
Provide a short and direct response. 1.02e+07. What is the difference between the Aid flow (current US$) in Pacific island small states in 1982 and the Aid flow (current US$) in Senegal in 1985?
Your response must be concise. 2.86e+06. What is the difference between the Aid flow (current US$) in Brunei Darussalam in 1982 and the Aid flow (current US$) in Panama in 1985?
Make the answer very short. -3.82e+06. What is the difference between the Aid flow (current US$) in Brunei Darussalam in 1982 and the Aid flow (current US$) in Senegal in 1985?
Your response must be concise. -1.12e+07. What is the difference between the Aid flow (current US$) of Panama in 1982 and the Aid flow (current US$) of Senegal in 1985?
Offer a terse response. -7.05e+06. What is the difference between the Aid flow (current US$) of Pacific island small states in 1982 and the Aid flow (current US$) of Brunei Darussalam in 1986?
Keep it short and to the point. 1.21e+07. What is the difference between the Aid flow (current US$) of Pacific island small states in 1982 and the Aid flow (current US$) of Panama in 1986?
Offer a terse response. 8.55e+06. What is the difference between the Aid flow (current US$) of Pacific island small states in 1982 and the Aid flow (current US$) of Senegal in 1986?
Make the answer very short. 1.53e+06. What is the difference between the Aid flow (current US$) in Brunei Darussalam in 1982 and the Aid flow (current US$) in Panama in 1986?
Your response must be concise. -5.48e+06. What is the difference between the Aid flow (current US$) of Brunei Darussalam in 1982 and the Aid flow (current US$) of Senegal in 1986?
Keep it short and to the point. -1.25e+07. What is the difference between the Aid flow (current US$) of Panama in 1982 and the Aid flow (current US$) of Senegal in 1986?
Provide a succinct answer. -8.38e+06. What is the difference between the Aid flow (current US$) in Pacific island small states in 1983 and the Aid flow (current US$) in Brunei Darussalam in 1984?
Offer a terse response. 1.09e+07. What is the difference between the Aid flow (current US$) in Pacific island small states in 1983 and the Aid flow (current US$) in Panama in 1984?
Provide a short and direct response. 6.70e+06. What is the difference between the Aid flow (current US$) of Pacific island small states in 1983 and the Aid flow (current US$) of Senegal in 1984?
Keep it short and to the point. -1.13e+06. What is the difference between the Aid flow (current US$) of Brunei Darussalam in 1983 and the Aid flow (current US$) of Panama in 1984?
Your answer should be compact. -4.48e+06. What is the difference between the Aid flow (current US$) in Brunei Darussalam in 1983 and the Aid flow (current US$) in Senegal in 1984?
Make the answer very short. -1.23e+07. What is the difference between the Aid flow (current US$) in Panama in 1983 and the Aid flow (current US$) in Senegal in 1984?
Offer a terse response. -8.44e+06. What is the difference between the Aid flow (current US$) in Pacific island small states in 1983 and the Aid flow (current US$) in Brunei Darussalam in 1985?
Your answer should be compact. 1.05e+07. What is the difference between the Aid flow (current US$) of Pacific island small states in 1983 and the Aid flow (current US$) of Panama in 1985?
Your answer should be compact. 7.48e+06. What is the difference between the Aid flow (current US$) in Pacific island small states in 1983 and the Aid flow (current US$) in Senegal in 1985?
Provide a succinct answer. 1.30e+05. What is the difference between the Aid flow (current US$) of Brunei Darussalam in 1983 and the Aid flow (current US$) of Panama in 1985?
Your response must be concise. -3.70e+06. What is the difference between the Aid flow (current US$) of Brunei Darussalam in 1983 and the Aid flow (current US$) of Senegal in 1985?
Offer a very short reply. -1.10e+07. What is the difference between the Aid flow (current US$) in Panama in 1983 and the Aid flow (current US$) in Senegal in 1985?
Make the answer very short. -7.18e+06. What is the difference between the Aid flow (current US$) in Pacific island small states in 1983 and the Aid flow (current US$) in Brunei Darussalam in 1986?
Give a very brief answer. 9.37e+06. What is the difference between the Aid flow (current US$) in Pacific island small states in 1983 and the Aid flow (current US$) in Panama in 1986?
Give a very brief answer. 5.82e+06. What is the difference between the Aid flow (current US$) of Pacific island small states in 1983 and the Aid flow (current US$) of Senegal in 1986?
Offer a terse response. -1.20e+06. What is the difference between the Aid flow (current US$) of Brunei Darussalam in 1983 and the Aid flow (current US$) of Panama in 1986?
Provide a succinct answer. -5.36e+06. What is the difference between the Aid flow (current US$) in Brunei Darussalam in 1983 and the Aid flow (current US$) in Senegal in 1986?
Provide a short and direct response. -1.24e+07. What is the difference between the Aid flow (current US$) in Panama in 1983 and the Aid flow (current US$) in Senegal in 1986?
Ensure brevity in your answer.  -8.51e+06. What is the difference between the Aid flow (current US$) of Pacific island small states in 1984 and the Aid flow (current US$) of Brunei Darussalam in 1985?
Your answer should be compact. 1.12e+07. What is the difference between the Aid flow (current US$) of Pacific island small states in 1984 and the Aid flow (current US$) of Panama in 1985?
Your answer should be very brief. 8.22e+06. What is the difference between the Aid flow (current US$) of Pacific island small states in 1984 and the Aid flow (current US$) of Senegal in 1985?
Offer a very short reply. 8.70e+05. What is the difference between the Aid flow (current US$) in Brunei Darussalam in 1984 and the Aid flow (current US$) in Panama in 1985?
Offer a terse response. -3.43e+06. What is the difference between the Aid flow (current US$) of Brunei Darussalam in 1984 and the Aid flow (current US$) of Senegal in 1985?
Your answer should be compact. -1.08e+07. What is the difference between the Aid flow (current US$) in Panama in 1984 and the Aid flow (current US$) in Senegal in 1985?
Offer a very short reply. -6.57e+06. What is the difference between the Aid flow (current US$) in Pacific island small states in 1984 and the Aid flow (current US$) in Brunei Darussalam in 1986?
Give a very brief answer. 1.01e+07. What is the difference between the Aid flow (current US$) of Pacific island small states in 1984 and the Aid flow (current US$) of Panama in 1986?
Offer a terse response. 6.56e+06. What is the difference between the Aid flow (current US$) in Pacific island small states in 1984 and the Aid flow (current US$) in Senegal in 1986?
Give a very brief answer. -4.60e+05. What is the difference between the Aid flow (current US$) of Brunei Darussalam in 1984 and the Aid flow (current US$) of Panama in 1986?
Offer a terse response. -5.09e+06. What is the difference between the Aid flow (current US$) in Brunei Darussalam in 1984 and the Aid flow (current US$) in Senegal in 1986?
Provide a short and direct response. -1.21e+07. What is the difference between the Aid flow (current US$) of Panama in 1984 and the Aid flow (current US$) of Senegal in 1986?
Keep it short and to the point. -7.90e+06. What is the difference between the Aid flow (current US$) of Pacific island small states in 1985 and the Aid flow (current US$) of Brunei Darussalam in 1986?
Keep it short and to the point. 1.36e+07. What is the difference between the Aid flow (current US$) of Pacific island small states in 1985 and the Aid flow (current US$) of Panama in 1986?
Provide a short and direct response. 1.00e+07. What is the difference between the Aid flow (current US$) in Pacific island small states in 1985 and the Aid flow (current US$) in Senegal in 1986?
Ensure brevity in your answer.  2.98e+06. What is the difference between the Aid flow (current US$) of Brunei Darussalam in 1985 and the Aid flow (current US$) of Panama in 1986?
Your response must be concise. -4.68e+06. What is the difference between the Aid flow (current US$) in Brunei Darussalam in 1985 and the Aid flow (current US$) in Senegal in 1986?
Your answer should be compact. -1.17e+07. What is the difference between the Aid flow (current US$) in Panama in 1985 and the Aid flow (current US$) in Senegal in 1986?
Your answer should be compact. -8.68e+06. What is the average Aid flow (current US$) of Pacific island small states per year?
Provide a short and direct response. 1.43e+07. What is the average Aid flow (current US$) in Brunei Darussalam per year?
Make the answer very short. 5.85e+05. What is the average Aid flow (current US$) of Panama per year?
Your answer should be compact. 3.93e+06. What is the average Aid flow (current US$) in Senegal per year?
Ensure brevity in your answer.  9.22e+06. In the year 1979, what is the difference between the Aid flow (current US$) in Pacific island small states and Aid flow (current US$) in Brunei Darussalam?
Keep it short and to the point. 8.38e+06. In the year 1979, what is the difference between the Aid flow (current US$) of Pacific island small states and Aid flow (current US$) of Panama?
Provide a succinct answer. 7.14e+06. In the year 1979, what is the difference between the Aid flow (current US$) of Pacific island small states and Aid flow (current US$) of Senegal?
Provide a succinct answer. 5.01e+06. In the year 1979, what is the difference between the Aid flow (current US$) in Brunei Darussalam and Aid flow (current US$) in Panama?
Your answer should be very brief. -1.24e+06. In the year 1979, what is the difference between the Aid flow (current US$) of Brunei Darussalam and Aid flow (current US$) of Senegal?
Give a very brief answer. -3.37e+06. In the year 1979, what is the difference between the Aid flow (current US$) in Panama and Aid flow (current US$) in Senegal?
Keep it short and to the point. -2.13e+06. In the year 1980, what is the difference between the Aid flow (current US$) of Pacific island small states and Aid flow (current US$) of Senegal?
Offer a very short reply. 4.09e+06. In the year 1980, what is the difference between the Aid flow (current US$) in Panama and Aid flow (current US$) in Senegal?
Provide a succinct answer. -2.91e+06. In the year 1981, what is the difference between the Aid flow (current US$) of Pacific island small states and Aid flow (current US$) of Brunei Darussalam?
Your answer should be very brief. 1.35e+07. In the year 1981, what is the difference between the Aid flow (current US$) in Pacific island small states and Aid flow (current US$) in Panama?
Ensure brevity in your answer.  8.44e+06. In the year 1981, what is the difference between the Aid flow (current US$) of Pacific island small states and Aid flow (current US$) of Senegal?
Provide a succinct answer. 5.49e+06. In the year 1981, what is the difference between the Aid flow (current US$) of Brunei Darussalam and Aid flow (current US$) of Panama?
Provide a succinct answer. -5.08e+06. In the year 1981, what is the difference between the Aid flow (current US$) in Brunei Darussalam and Aid flow (current US$) in Senegal?
Offer a terse response. -8.03e+06. In the year 1981, what is the difference between the Aid flow (current US$) in Panama and Aid flow (current US$) in Senegal?
Ensure brevity in your answer.  -2.95e+06. In the year 1982, what is the difference between the Aid flow (current US$) of Pacific island small states and Aid flow (current US$) of Brunei Darussalam?
Your answer should be compact. 1.40e+07. In the year 1982, what is the difference between the Aid flow (current US$) of Pacific island small states and Aid flow (current US$) of Panama?
Keep it short and to the point. 9.91e+06. In the year 1982, what is the difference between the Aid flow (current US$) of Pacific island small states and Aid flow (current US$) of Senegal?
Provide a succinct answer. 8.41e+06. In the year 1982, what is the difference between the Aid flow (current US$) in Brunei Darussalam and Aid flow (current US$) in Panama?
Your answer should be compact. -4.12e+06. In the year 1982, what is the difference between the Aid flow (current US$) of Brunei Darussalam and Aid flow (current US$) of Senegal?
Offer a very short reply. -5.62e+06. In the year 1982, what is the difference between the Aid flow (current US$) in Panama and Aid flow (current US$) in Senegal?
Offer a very short reply. -1.50e+06. In the year 1983, what is the difference between the Aid flow (current US$) of Pacific island small states and Aid flow (current US$) of Brunei Darussalam?
Provide a short and direct response. 1.12e+07. In the year 1983, what is the difference between the Aid flow (current US$) in Pacific island small states and Aid flow (current US$) in Panama?
Your answer should be compact. 7.31e+06. In the year 1983, what is the difference between the Aid flow (current US$) in Pacific island small states and Aid flow (current US$) in Senegal?
Offer a very short reply. -3.36e+06. In the year 1983, what is the difference between the Aid flow (current US$) in Brunei Darussalam and Aid flow (current US$) in Panama?
Offer a terse response. -3.87e+06. In the year 1983, what is the difference between the Aid flow (current US$) in Brunei Darussalam and Aid flow (current US$) in Senegal?
Make the answer very short. -1.45e+07. In the year 1983, what is the difference between the Aid flow (current US$) of Panama and Aid flow (current US$) of Senegal?
Ensure brevity in your answer.  -1.07e+07. In the year 1984, what is the difference between the Aid flow (current US$) in Pacific island small states and Aid flow (current US$) in Brunei Darussalam?
Provide a short and direct response. 1.16e+07. In the year 1984, what is the difference between the Aid flow (current US$) of Pacific island small states and Aid flow (current US$) of Panama?
Provide a short and direct response. 7.44e+06. In the year 1984, what is the difference between the Aid flow (current US$) in Pacific island small states and Aid flow (current US$) in Senegal?
Your answer should be very brief. -3.90e+05. In the year 1984, what is the difference between the Aid flow (current US$) of Brunei Darussalam and Aid flow (current US$) of Panama?
Make the answer very short. -4.21e+06. In the year 1984, what is the difference between the Aid flow (current US$) of Brunei Darussalam and Aid flow (current US$) of Senegal?
Ensure brevity in your answer.  -1.20e+07. In the year 1984, what is the difference between the Aid flow (current US$) of Panama and Aid flow (current US$) of Senegal?
Make the answer very short. -7.83e+06. In the year 1985, what is the difference between the Aid flow (current US$) of Pacific island small states and Aid flow (current US$) of Brunei Darussalam?
Keep it short and to the point. 1.47e+07. In the year 1985, what is the difference between the Aid flow (current US$) of Pacific island small states and Aid flow (current US$) of Panama?
Provide a short and direct response. 1.17e+07. In the year 1985, what is the difference between the Aid flow (current US$) of Pacific island small states and Aid flow (current US$) of Senegal?
Offer a very short reply. 4.31e+06. In the year 1985, what is the difference between the Aid flow (current US$) of Brunei Darussalam and Aid flow (current US$) of Panama?
Your response must be concise. -3.02e+06. In the year 1985, what is the difference between the Aid flow (current US$) of Brunei Darussalam and Aid flow (current US$) of Senegal?
Your response must be concise. -1.04e+07. In the year 1985, what is the difference between the Aid flow (current US$) in Panama and Aid flow (current US$) in Senegal?
Ensure brevity in your answer.  -7.35e+06. In the year 1986, what is the difference between the Aid flow (current US$) in Pacific island small states and Aid flow (current US$) in Brunei Darussalam?
Offer a terse response. 2.80e+07. In the year 1986, what is the difference between the Aid flow (current US$) of Pacific island small states and Aid flow (current US$) of Panama?
Your answer should be very brief. 2.44e+07. In the year 1986, what is the difference between the Aid flow (current US$) in Pacific island small states and Aid flow (current US$) in Senegal?
Your answer should be compact. 1.74e+07. In the year 1986, what is the difference between the Aid flow (current US$) of Brunei Darussalam and Aid flow (current US$) of Panama?
Your answer should be compact. -3.55e+06. In the year 1986, what is the difference between the Aid flow (current US$) in Brunei Darussalam and Aid flow (current US$) in Senegal?
Give a very brief answer. -1.06e+07. In the year 1986, what is the difference between the Aid flow (current US$) of Panama and Aid flow (current US$) of Senegal?
Keep it short and to the point. -7.02e+06. What is the ratio of the Aid flow (current US$) in Pacific island small states in 1979 to that in 1980?
Provide a short and direct response. 0.97. What is the ratio of the Aid flow (current US$) of Panama in 1979 to that in 1980?
Your response must be concise. 0.77. What is the ratio of the Aid flow (current US$) in Senegal in 1979 to that in 1980?
Your response must be concise. 0.75. What is the ratio of the Aid flow (current US$) in Pacific island small states in 1979 to that in 1981?
Keep it short and to the point. 0.61. What is the ratio of the Aid flow (current US$) in Brunei Darussalam in 1979 to that in 1981?
Your response must be concise. 0.12. What is the ratio of the Aid flow (current US$) of Panama in 1979 to that in 1981?
Your response must be concise. 0.24. What is the ratio of the Aid flow (current US$) of Senegal in 1979 to that in 1981?
Your answer should be very brief. 0.41. What is the ratio of the Aid flow (current US$) in Pacific island small states in 1979 to that in 1982?
Your response must be concise. 0.59. What is the ratio of the Aid flow (current US$) of Brunei Darussalam in 1979 to that in 1982?
Your response must be concise. 0.08. What is the ratio of the Aid flow (current US$) of Panama in 1979 to that in 1982?
Your response must be concise. 0.29. What is the ratio of the Aid flow (current US$) of Senegal in 1979 to that in 1982?
Make the answer very short. 0.58. What is the ratio of the Aid flow (current US$) of Pacific island small states in 1979 to that in 1983?
Keep it short and to the point. 0.73. What is the ratio of the Aid flow (current US$) in Brunei Darussalam in 1979 to that in 1983?
Provide a succinct answer. 0.05. What is the ratio of the Aid flow (current US$) in Panama in 1979 to that in 1983?
Give a very brief answer. 0.3. What is the ratio of the Aid flow (current US$) in Senegal in 1979 to that in 1983?
Keep it short and to the point. 0.23. What is the ratio of the Aid flow (current US$) of Pacific island small states in 1979 to that in 1984?
Your answer should be very brief. 0.68. What is the ratio of the Aid flow (current US$) of Brunei Darussalam in 1979 to that in 1984?
Provide a short and direct response. 0.03. What is the ratio of the Aid flow (current US$) of Panama in 1979 to that in 1984?
Ensure brevity in your answer.  0.26. What is the ratio of the Aid flow (current US$) of Senegal in 1979 to that in 1984?
Your answer should be compact. 0.27. What is the ratio of the Aid flow (current US$) of Pacific island small states in 1979 to that in 1985?
Your answer should be compact. 0.53. What is the ratio of the Aid flow (current US$) of Brunei Darussalam in 1979 to that in 1985?
Give a very brief answer. 0.02. What is the ratio of the Aid flow (current US$) of Panama in 1979 to that in 1985?
Your answer should be compact. 0.31. What is the ratio of the Aid flow (current US$) of Senegal in 1979 to that in 1985?
Your answer should be very brief. 0.3. What is the ratio of the Aid flow (current US$) in Pacific island small states in 1979 to that in 1986?
Your response must be concise. 0.28. What is the ratio of the Aid flow (current US$) of Brunei Darussalam in 1979 to that in 1986?
Provide a short and direct response. 0.01. What is the ratio of the Aid flow (current US$) of Panama in 1979 to that in 1986?
Your response must be concise. 0.22. What is the ratio of the Aid flow (current US$) of Senegal in 1979 to that in 1986?
Give a very brief answer. 0.27. What is the ratio of the Aid flow (current US$) in Pacific island small states in 1980 to that in 1981?
Give a very brief answer. 0.63. What is the ratio of the Aid flow (current US$) of Panama in 1980 to that in 1981?
Offer a very short reply. 0.31. What is the ratio of the Aid flow (current US$) of Senegal in 1980 to that in 1981?
Ensure brevity in your answer.  0.55. What is the ratio of the Aid flow (current US$) of Pacific island small states in 1980 to that in 1982?
Your answer should be compact. 0.6. What is the ratio of the Aid flow (current US$) of Panama in 1980 to that in 1982?
Make the answer very short. 0.38. What is the ratio of the Aid flow (current US$) in Senegal in 1980 to that in 1982?
Your answer should be compact. 0.78. What is the ratio of the Aid flow (current US$) of Pacific island small states in 1980 to that in 1983?
Your response must be concise. 0.75. What is the ratio of the Aid flow (current US$) of Panama in 1980 to that in 1983?
Your response must be concise. 0.39. What is the ratio of the Aid flow (current US$) in Senegal in 1980 to that in 1983?
Offer a very short reply. 0.31. What is the ratio of the Aid flow (current US$) of Pacific island small states in 1980 to that in 1984?
Your answer should be very brief. 0.7. What is the ratio of the Aid flow (current US$) in Panama in 1980 to that in 1984?
Ensure brevity in your answer.  0.34. What is the ratio of the Aid flow (current US$) in Senegal in 1980 to that in 1984?
Your answer should be compact. 0.36. What is the ratio of the Aid flow (current US$) of Pacific island small states in 1980 to that in 1985?
Ensure brevity in your answer.  0.55. What is the ratio of the Aid flow (current US$) of Panama in 1980 to that in 1985?
Give a very brief answer. 0.4. What is the ratio of the Aid flow (current US$) of Senegal in 1980 to that in 1985?
Offer a very short reply. 0.4. What is the ratio of the Aid flow (current US$) in Pacific island small states in 1980 to that in 1986?
Ensure brevity in your answer.  0.29. What is the ratio of the Aid flow (current US$) in Panama in 1980 to that in 1986?
Ensure brevity in your answer.  0.29. What is the ratio of the Aid flow (current US$) in Senegal in 1980 to that in 1986?
Offer a very short reply. 0.36. What is the ratio of the Aid flow (current US$) in Pacific island small states in 1981 to that in 1982?
Give a very brief answer. 0.96. What is the ratio of the Aid flow (current US$) of Brunei Darussalam in 1981 to that in 1982?
Your response must be concise. 0.68. What is the ratio of the Aid flow (current US$) of Panama in 1981 to that in 1982?
Offer a terse response. 1.2. What is the ratio of the Aid flow (current US$) in Senegal in 1981 to that in 1982?
Keep it short and to the point. 1.4. What is the ratio of the Aid flow (current US$) in Pacific island small states in 1981 to that in 1983?
Provide a succinct answer. 1.19. What is the ratio of the Aid flow (current US$) in Brunei Darussalam in 1981 to that in 1983?
Give a very brief answer. 0.46. What is the ratio of the Aid flow (current US$) of Panama in 1981 to that in 1983?
Offer a very short reply. 1.24. What is the ratio of the Aid flow (current US$) in Senegal in 1981 to that in 1983?
Keep it short and to the point. 0.55. What is the ratio of the Aid flow (current US$) of Pacific island small states in 1981 to that in 1984?
Offer a terse response. 1.11. What is the ratio of the Aid flow (current US$) in Brunei Darussalam in 1981 to that in 1984?
Your response must be concise. 0.27. What is the ratio of the Aid flow (current US$) of Panama in 1981 to that in 1984?
Offer a very short reply. 1.08. What is the ratio of the Aid flow (current US$) in Senegal in 1981 to that in 1984?
Your response must be concise. 0.65. What is the ratio of the Aid flow (current US$) in Pacific island small states in 1981 to that in 1985?
Provide a short and direct response. 0.87. What is the ratio of the Aid flow (current US$) in Brunei Darussalam in 1981 to that in 1985?
Provide a succinct answer. 0.16. What is the ratio of the Aid flow (current US$) of Panama in 1981 to that in 1985?
Provide a succinct answer. 1.29. What is the ratio of the Aid flow (current US$) of Senegal in 1981 to that in 1985?
Your answer should be very brief. 0.72. What is the ratio of the Aid flow (current US$) in Pacific island small states in 1981 to that in 1986?
Ensure brevity in your answer.  0.45. What is the ratio of the Aid flow (current US$) of Brunei Darussalam in 1981 to that in 1986?
Your answer should be very brief. 0.08. What is the ratio of the Aid flow (current US$) in Panama in 1981 to that in 1986?
Make the answer very short. 0.92. What is the ratio of the Aid flow (current US$) of Senegal in 1981 to that in 1986?
Offer a very short reply. 0.64. What is the ratio of the Aid flow (current US$) in Pacific island small states in 1982 to that in 1983?
Ensure brevity in your answer.  1.24. What is the ratio of the Aid flow (current US$) in Brunei Darussalam in 1982 to that in 1983?
Offer a very short reply. 0.68. What is the ratio of the Aid flow (current US$) in Panama in 1982 to that in 1983?
Provide a short and direct response. 1.03. What is the ratio of the Aid flow (current US$) in Senegal in 1982 to that in 1983?
Your response must be concise. 0.39. What is the ratio of the Aid flow (current US$) of Pacific island small states in 1982 to that in 1984?
Your answer should be very brief. 1.16. What is the ratio of the Aid flow (current US$) in Brunei Darussalam in 1982 to that in 1984?
Provide a short and direct response. 0.39. What is the ratio of the Aid flow (current US$) of Panama in 1982 to that in 1984?
Keep it short and to the point. 0.9. What is the ratio of the Aid flow (current US$) of Senegal in 1982 to that in 1984?
Your answer should be very brief. 0.46. What is the ratio of the Aid flow (current US$) of Pacific island small states in 1982 to that in 1985?
Your answer should be compact. 0.91. What is the ratio of the Aid flow (current US$) of Brunei Darussalam in 1982 to that in 1985?
Your answer should be very brief. 0.24. What is the ratio of the Aid flow (current US$) in Panama in 1982 to that in 1985?
Give a very brief answer. 1.07. What is the ratio of the Aid flow (current US$) in Senegal in 1982 to that in 1985?
Offer a terse response. 0.51. What is the ratio of the Aid flow (current US$) of Pacific island small states in 1982 to that in 1986?
Your answer should be very brief. 0.47. What is the ratio of the Aid flow (current US$) of Brunei Darussalam in 1982 to that in 1986?
Ensure brevity in your answer.  0.11. What is the ratio of the Aid flow (current US$) of Panama in 1982 to that in 1986?
Make the answer very short. 0.76. What is the ratio of the Aid flow (current US$) in Senegal in 1982 to that in 1986?
Offer a very short reply. 0.46. What is the ratio of the Aid flow (current US$) of Pacific island small states in 1983 to that in 1984?
Make the answer very short. 0.94. What is the ratio of the Aid flow (current US$) in Brunei Darussalam in 1983 to that in 1984?
Provide a short and direct response. 0.58. What is the ratio of the Aid flow (current US$) in Panama in 1983 to that in 1984?
Your answer should be compact. 0.87. What is the ratio of the Aid flow (current US$) of Senegal in 1983 to that in 1984?
Ensure brevity in your answer.  1.18. What is the ratio of the Aid flow (current US$) of Pacific island small states in 1983 to that in 1985?
Ensure brevity in your answer.  0.73. What is the ratio of the Aid flow (current US$) of Brunei Darussalam in 1983 to that in 1985?
Make the answer very short. 0.35. What is the ratio of the Aid flow (current US$) in Panama in 1983 to that in 1985?
Ensure brevity in your answer.  1.04. What is the ratio of the Aid flow (current US$) of Senegal in 1983 to that in 1985?
Give a very brief answer. 1.31. What is the ratio of the Aid flow (current US$) in Pacific island small states in 1983 to that in 1986?
Provide a short and direct response. 0.38. What is the ratio of the Aid flow (current US$) in Brunei Darussalam in 1983 to that in 1986?
Offer a terse response. 0.17. What is the ratio of the Aid flow (current US$) of Panama in 1983 to that in 1986?
Your response must be concise. 0.74. What is the ratio of the Aid flow (current US$) in Senegal in 1983 to that in 1986?
Your answer should be very brief. 1.17. What is the ratio of the Aid flow (current US$) in Pacific island small states in 1984 to that in 1985?
Your answer should be compact. 0.78. What is the ratio of the Aid flow (current US$) in Brunei Darussalam in 1984 to that in 1985?
Your answer should be compact. 0.61. What is the ratio of the Aid flow (current US$) in Panama in 1984 to that in 1985?
Your answer should be very brief. 1.19. What is the ratio of the Aid flow (current US$) of Senegal in 1984 to that in 1985?
Your response must be concise. 1.11. What is the ratio of the Aid flow (current US$) in Pacific island small states in 1984 to that in 1986?
Ensure brevity in your answer.  0.41. What is the ratio of the Aid flow (current US$) of Brunei Darussalam in 1984 to that in 1986?
Provide a succinct answer. 0.29. What is the ratio of the Aid flow (current US$) in Panama in 1984 to that in 1986?
Your response must be concise. 0.85. What is the ratio of the Aid flow (current US$) in Senegal in 1984 to that in 1986?
Your answer should be very brief. 0.99. What is the ratio of the Aid flow (current US$) of Pacific island small states in 1985 to that in 1986?
Make the answer very short. 0.52. What is the ratio of the Aid flow (current US$) in Brunei Darussalam in 1985 to that in 1986?
Offer a terse response. 0.48. What is the ratio of the Aid flow (current US$) of Panama in 1985 to that in 1986?
Provide a succinct answer. 0.71. What is the ratio of the Aid flow (current US$) of Senegal in 1985 to that in 1986?
Your answer should be very brief. 0.9. What is the difference between the highest and the second highest Aid flow (current US$) in Pacific island small states?
Provide a short and direct response. 1.44e+07. What is the difference between the highest and the second highest Aid flow (current US$) of Brunei Darussalam?
Your answer should be very brief. 1.13e+06. What is the difference between the highest and the second highest Aid flow (current US$) in Senegal?
Offer a terse response. 2.16e+06. What is the difference between the highest and the lowest Aid flow (current US$) of Pacific island small states?
Your response must be concise. 2.18e+07. What is the difference between the highest and the lowest Aid flow (current US$) of Brunei Darussalam?
Provide a succinct answer. 2.18e+06. What is the difference between the highest and the lowest Aid flow (current US$) in Panama?
Provide a succinct answer. 4.47e+06. What is the difference between the highest and the lowest Aid flow (current US$) in Senegal?
Your answer should be very brief. 1.15e+07. 